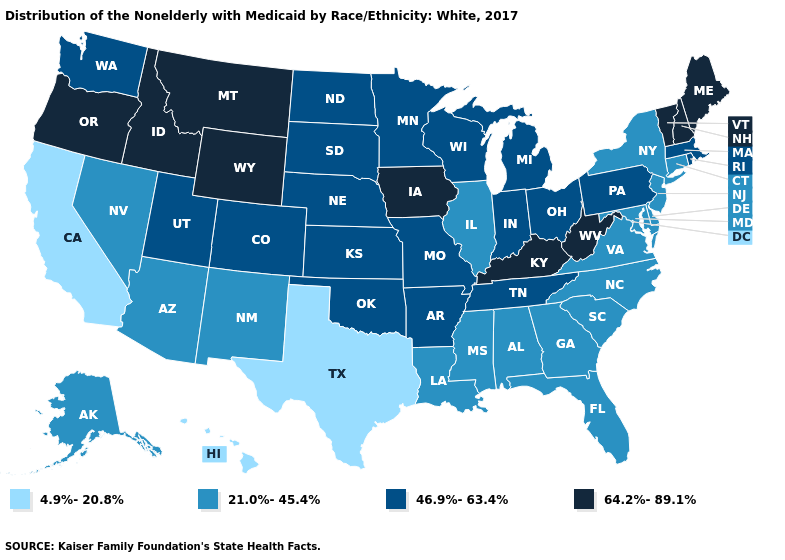What is the value of Ohio?
Answer briefly. 46.9%-63.4%. What is the value of Arizona?
Answer briefly. 21.0%-45.4%. Does Arizona have the highest value in the USA?
Answer briefly. No. What is the highest value in the Northeast ?
Keep it brief. 64.2%-89.1%. Name the states that have a value in the range 21.0%-45.4%?
Quick response, please. Alabama, Alaska, Arizona, Connecticut, Delaware, Florida, Georgia, Illinois, Louisiana, Maryland, Mississippi, Nevada, New Jersey, New Mexico, New York, North Carolina, South Carolina, Virginia. Among the states that border Louisiana , which have the lowest value?
Give a very brief answer. Texas. Name the states that have a value in the range 46.9%-63.4%?
Answer briefly. Arkansas, Colorado, Indiana, Kansas, Massachusetts, Michigan, Minnesota, Missouri, Nebraska, North Dakota, Ohio, Oklahoma, Pennsylvania, Rhode Island, South Dakota, Tennessee, Utah, Washington, Wisconsin. Name the states that have a value in the range 46.9%-63.4%?
Short answer required. Arkansas, Colorado, Indiana, Kansas, Massachusetts, Michigan, Minnesota, Missouri, Nebraska, North Dakota, Ohio, Oklahoma, Pennsylvania, Rhode Island, South Dakota, Tennessee, Utah, Washington, Wisconsin. Does Minnesota have the lowest value in the USA?
Keep it brief. No. Name the states that have a value in the range 21.0%-45.4%?
Quick response, please. Alabama, Alaska, Arizona, Connecticut, Delaware, Florida, Georgia, Illinois, Louisiana, Maryland, Mississippi, Nevada, New Jersey, New Mexico, New York, North Carolina, South Carolina, Virginia. Name the states that have a value in the range 21.0%-45.4%?
Short answer required. Alabama, Alaska, Arizona, Connecticut, Delaware, Florida, Georgia, Illinois, Louisiana, Maryland, Mississippi, Nevada, New Jersey, New Mexico, New York, North Carolina, South Carolina, Virginia. Name the states that have a value in the range 4.9%-20.8%?
Keep it brief. California, Hawaii, Texas. What is the highest value in the MidWest ?
Be succinct. 64.2%-89.1%. Is the legend a continuous bar?
Quick response, please. No. What is the value of Washington?
Keep it brief. 46.9%-63.4%. 